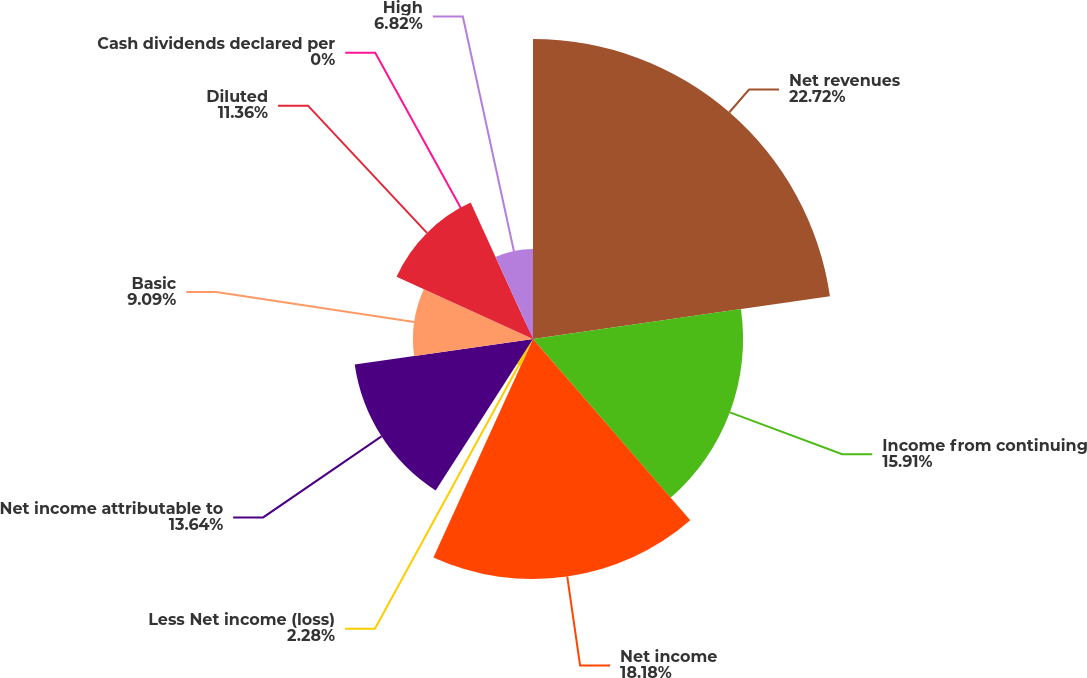Convert chart to OTSL. <chart><loc_0><loc_0><loc_500><loc_500><pie_chart><fcel>Net revenues<fcel>Income from continuing<fcel>Net income<fcel>Less Net income (loss)<fcel>Net income attributable to<fcel>Basic<fcel>Diluted<fcel>Cash dividends declared per<fcel>High<nl><fcel>22.72%<fcel>15.91%<fcel>18.18%<fcel>2.28%<fcel>13.64%<fcel>9.09%<fcel>11.36%<fcel>0.0%<fcel>6.82%<nl></chart> 